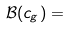<formula> <loc_0><loc_0><loc_500><loc_500>\mathcal { B } ( c _ { g } ) = \\</formula> 